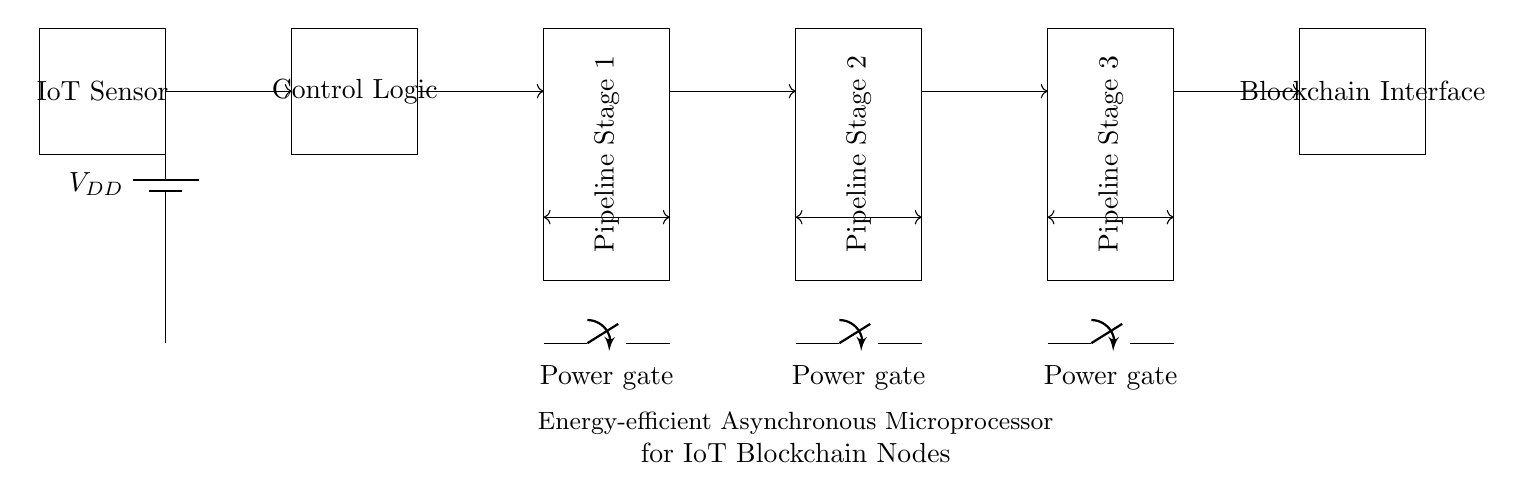What is the primary power supply voltage in this circuit? The circuit includes a battery, labeled as V_DD, which represents the power supply voltage. Since the specific numeric value isn't shown, we'll refer to the label directly.
Answer: V_DD What component connects the IoT sensor to the control logic? The IoT sensor is connected to the control logic through a direct line, indicating a signal connection, which likely carries data from the sensor to the control logic.
Answer: Direct line How many pipeline stages are shown in this circuit? The diagram displays three pipeline stages, each represented as a rectangle labeled as Pipeline Stage 1, 2, and 3.
Answer: Three What type of signals are exchanged between the pipeline stages? The signals are handshake signals, which are typically used in asynchronous circuits to synchronize the operation between different components or stages.
Answer: Handshake signals What is the purpose of the power gates in this circuit? The power gates are used to control the connection of power to each pipeline stage, allowing for energy efficiency by providing power only when necessary.
Answer: Energy efficiency What unique feature does this microprocessor circuit implement for its operation? This circuit implements an asynchronous operation feature, which allows it to function without a global clock, enhancing its responsiveness and energy efficiency for IoT applications.
Answer: Asynchronous operation What part of the circuit serves as the interface with the blockchain? The blockchain interface is a designated component of the circuit, illustrated as a rectangle, which communicates with the previous pipeline stage and handles blockchain transactions.
Answer: Blockchain Interface 